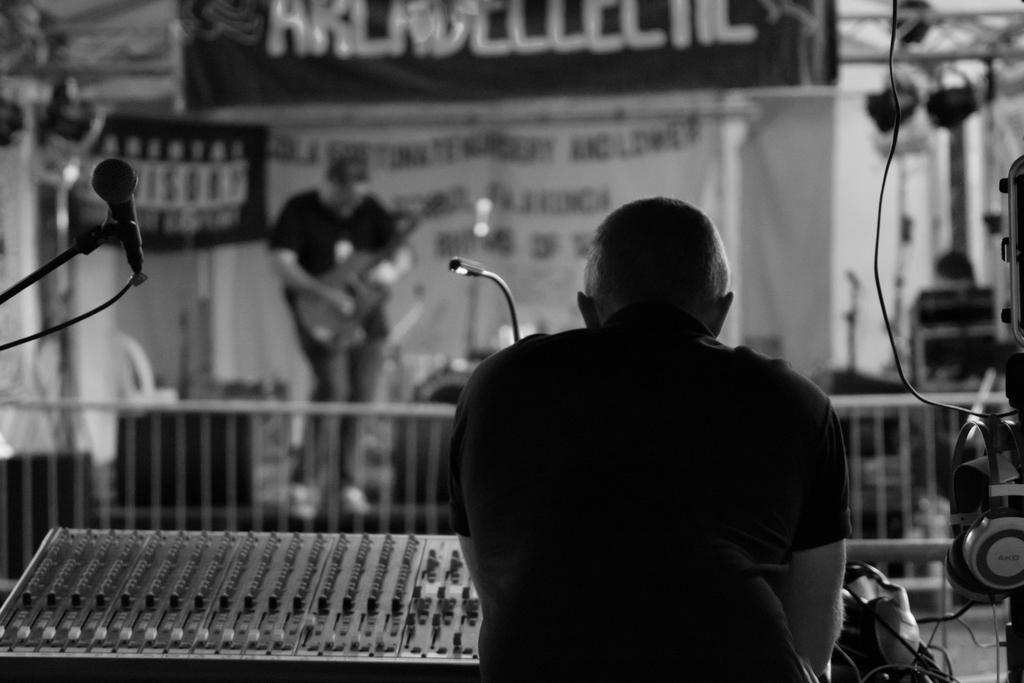Can you describe this image briefly? This image consists of two persons. In the front, the man is playing a music mixer. In the background, there is a man playing guitar. And there are banners along with the mics. To the right, there are headphones. 